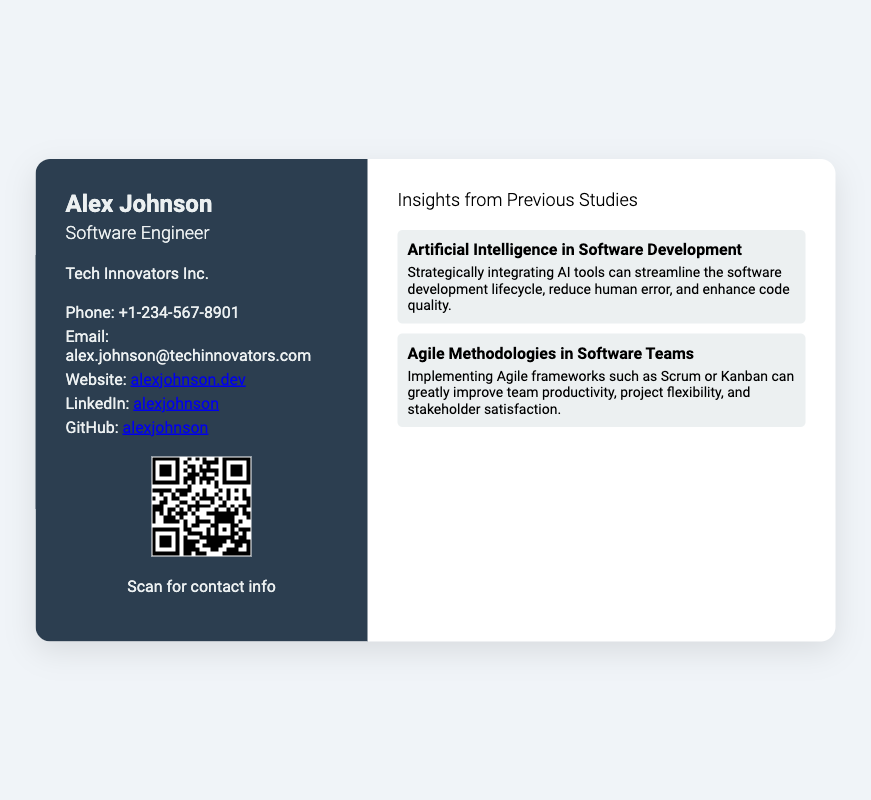What is the name of the individual on the card? The name displayed prominently at the top of the card is Alex Johnson.
Answer: Alex Johnson What is Alex Johnson's job title? The job title mentioned below the name is Software Engineer.
Answer: Software Engineer What company does Alex work for? The company name is listed under the job title as Tech Innovators Inc.
Answer: Tech Innovators Inc What is the phone number provided? The phone number is specified in the contact information section as +1-234-567-8901.
Answer: +1-234-567-8901 What is Alex's email address? The email address is presented in the contact information as alex.johnson@techinnovators.com.
Answer: alex.johnson@techinnovators.com How many insights are listed in the document? There are two insights provided in the insights section.
Answer: 2 What topic does the first insight cover? The first insight focuses on Artificial Intelligence in Software Development.
Answer: Artificial Intelligence in Software Development What does the QR code link to? The QR code is associated with the contact information page found at the URL provided.
Answer: https://alexjohnson.dev/contact What is the main color of the left section of the card? The left section's background color is described as dark blue, which corresponds with the color code #2c3e50.
Answer: Dark blue 